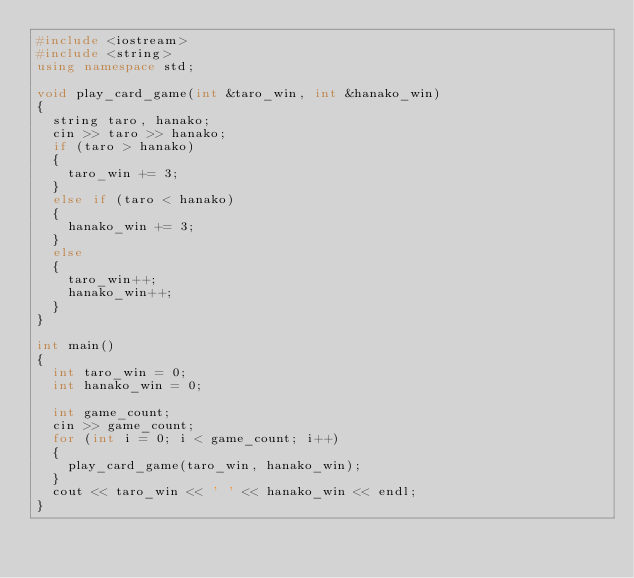Convert code to text. <code><loc_0><loc_0><loc_500><loc_500><_C++_>#include <iostream>
#include <string>
using namespace std;

void play_card_game(int &taro_win, int &hanako_win)
{
  string taro, hanako;
  cin >> taro >> hanako;
  if (taro > hanako)
  {
    taro_win += 3;
  }
  else if (taro < hanako)
  {
    hanako_win += 3;
  }
  else
  {
    taro_win++;
    hanako_win++;
  }
}

int main()
{
  int taro_win = 0;
  int hanako_win = 0;

  int game_count;
  cin >> game_count;
  for (int i = 0; i < game_count; i++)
  {
    play_card_game(taro_win, hanako_win);
  }
  cout << taro_win << ' ' << hanako_win << endl;
}

</code> 